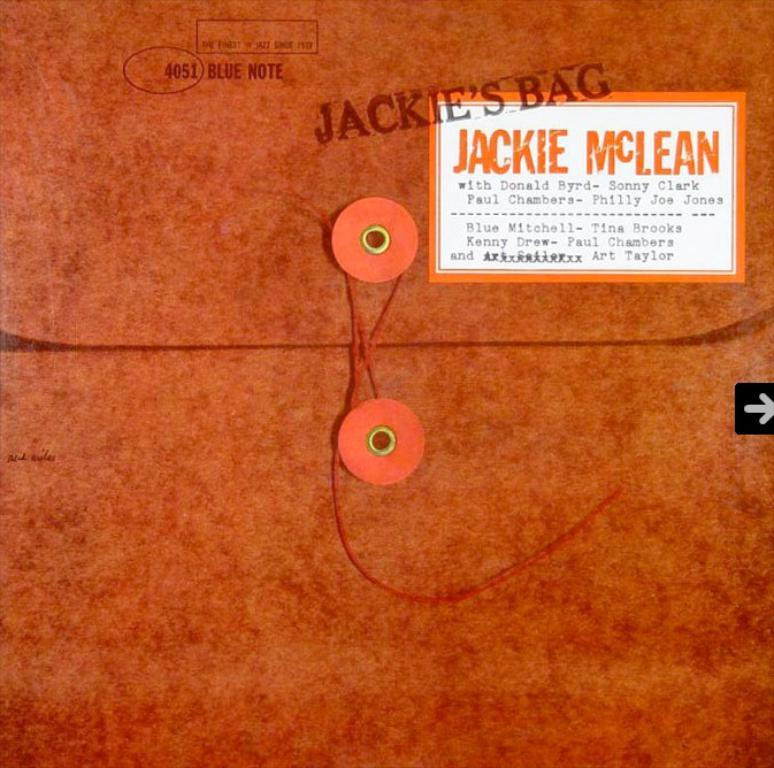<image>
Relay a brief, clear account of the picture shown. An orange file folder with a stamp that says Jackie 